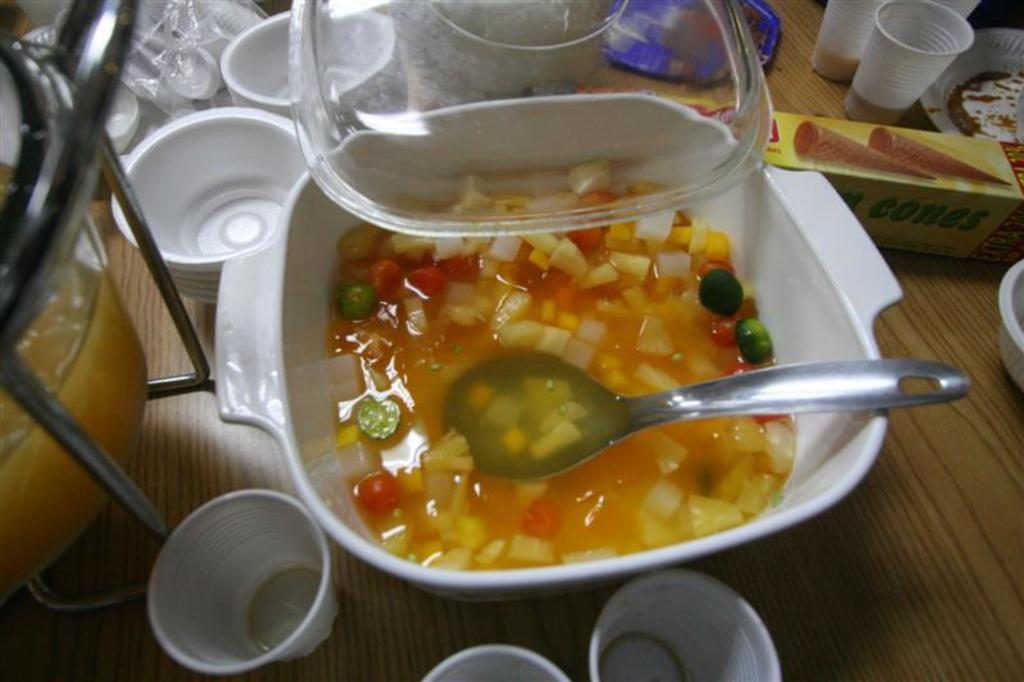Please provide a concise description of this image. We can see bowl with soup,spoon,glasses,cups,stand,lid,box and some objects on the wooden surface. 